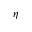<formula> <loc_0><loc_0><loc_500><loc_500>\eta</formula> 